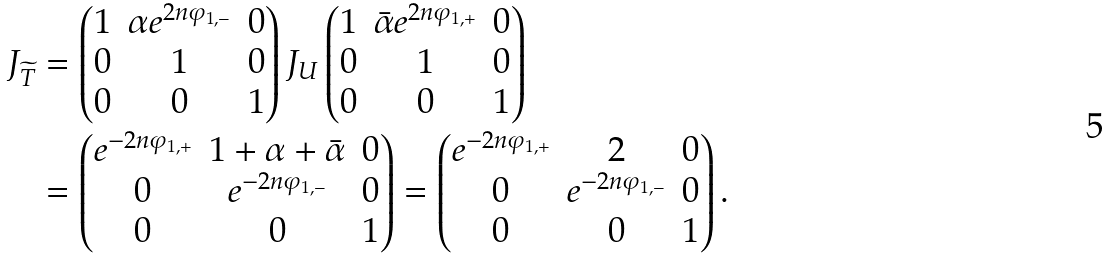Convert formula to latex. <formula><loc_0><loc_0><loc_500><loc_500>J _ { \widetilde { T } } & = \begin{pmatrix} 1 & \alpha e ^ { 2 n \varphi _ { 1 , - } } & 0 \\ 0 & 1 & 0 \\ 0 & 0 & 1 \end{pmatrix} J _ { U } \begin{pmatrix} 1 & \bar { \alpha } e ^ { 2 n \varphi _ { 1 , + } } & 0 \\ 0 & 1 & 0 \\ 0 & 0 & 1 \end{pmatrix} \\ & = \begin{pmatrix} e ^ { - 2 n \varphi _ { 1 , + } } & 1 + \alpha + \bar { \alpha } & 0 \\ 0 & e ^ { - 2 n \varphi _ { 1 , - } } & 0 \\ 0 & 0 & 1 \end{pmatrix} = \begin{pmatrix} e ^ { - 2 n \varphi _ { 1 , + } } & 2 & 0 \\ 0 & e ^ { - 2 n \varphi _ { 1 , - } } & 0 \\ 0 & 0 & 1 \end{pmatrix} .</formula> 